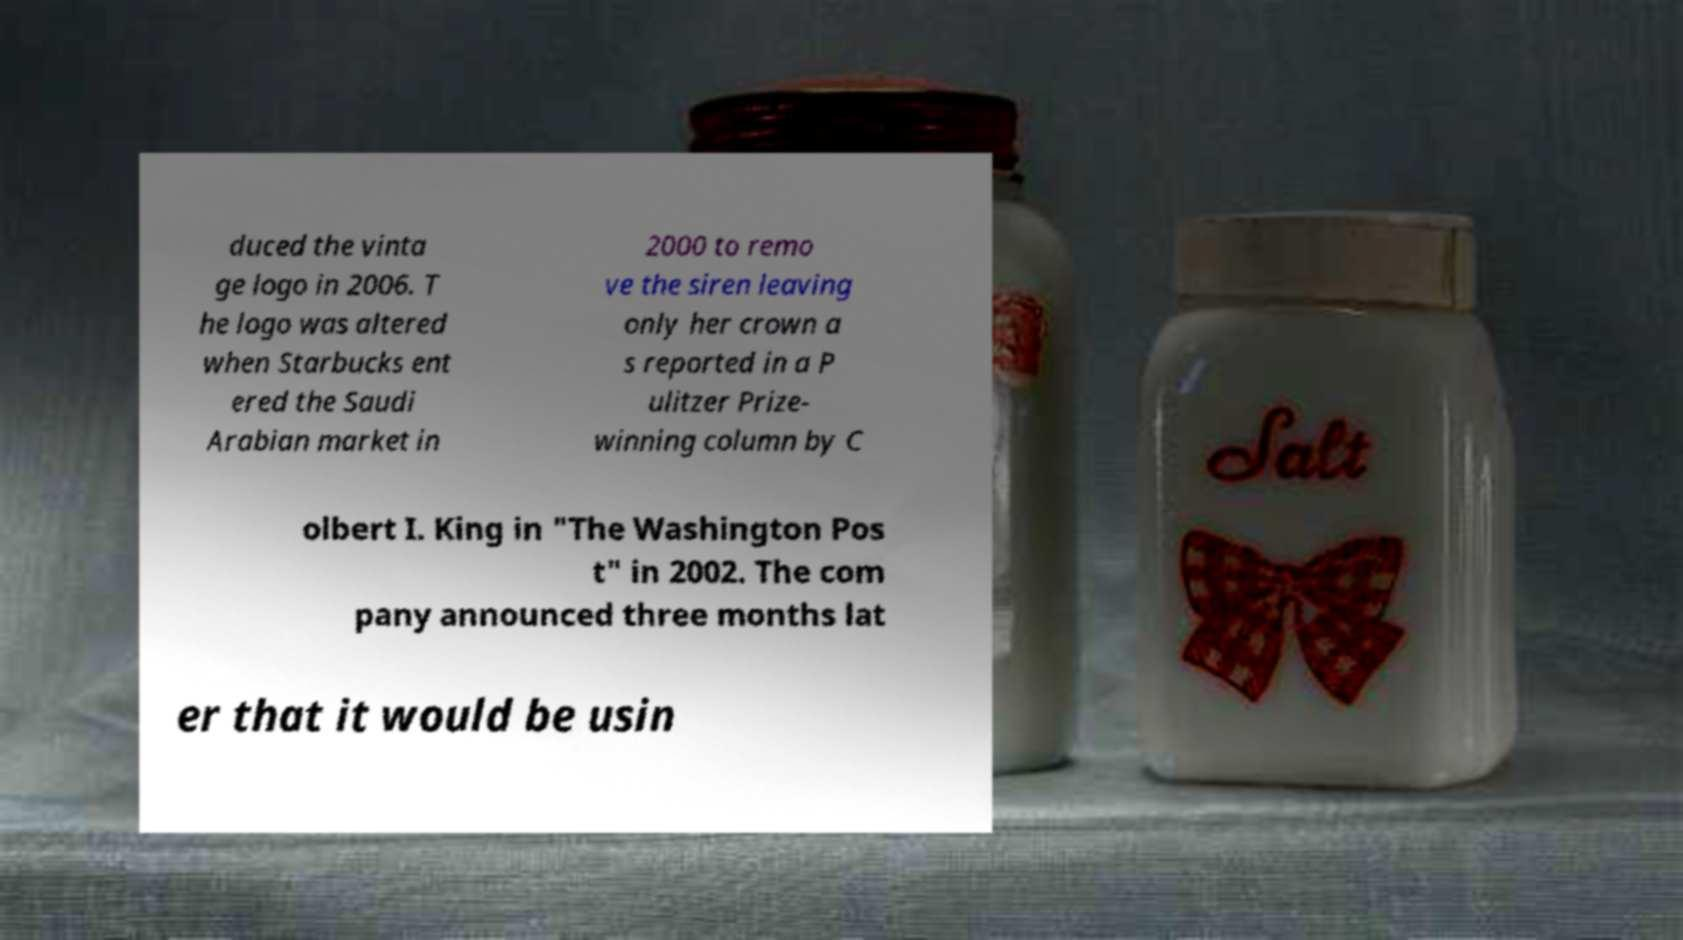Can you read and provide the text displayed in the image?This photo seems to have some interesting text. Can you extract and type it out for me? duced the vinta ge logo in 2006. T he logo was altered when Starbucks ent ered the Saudi Arabian market in 2000 to remo ve the siren leaving only her crown a s reported in a P ulitzer Prize- winning column by C olbert I. King in "The Washington Pos t" in 2002. The com pany announced three months lat er that it would be usin 